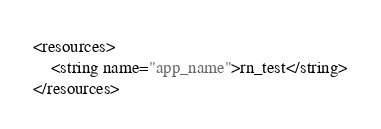<code> <loc_0><loc_0><loc_500><loc_500><_XML_><resources>
    <string name="app_name">rn_test</string>
</resources>
</code> 